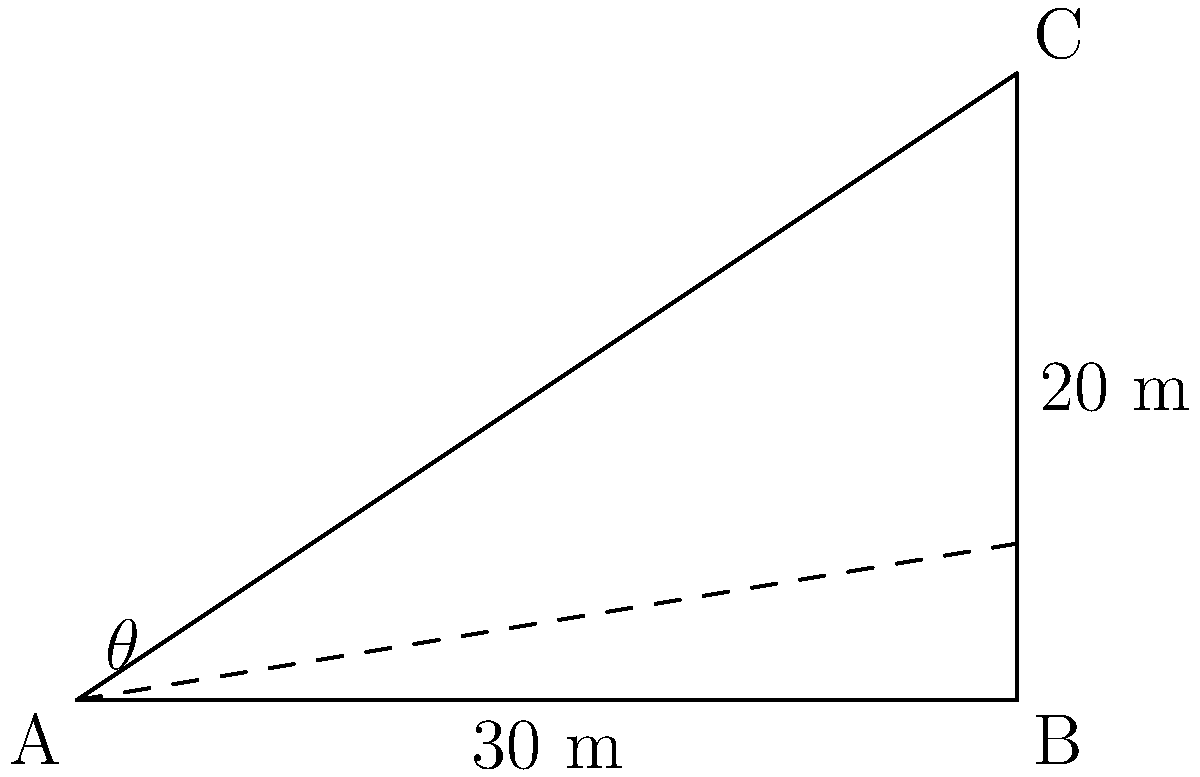As a computer science student working on a project involving 3D graphics and trigonometry, you need to calculate the angle of elevation for proper camera positioning. Given a building with a height of 20 meters and an observer standing 30 meters away from its base, what is the angle of elevation (θ) from the observer's eye level to the top of the building? Round your answer to the nearest degree. To solve this problem, we'll use the tangent function from trigonometry. Here's a step-by-step approach:

1) In this scenario, we have a right triangle where:
   - The adjacent side (distance from the observer to the building) is 30 meters
   - The opposite side (height of the building) is 20 meters
   - We need to find the angle θ

2) The tangent of an angle in a right triangle is defined as the ratio of the opposite side to the adjacent side:

   $$\tan(\theta) = \frac{\text{opposite}}{\text{adjacent}}$$

3) Substituting our known values:

   $$\tan(\theta) = \frac{20}{30}$$

4) Simplify the fraction:

   $$\tan(\theta) = \frac{2}{3}$$

5) To find θ, we need to use the inverse tangent (arctan or tan^(-1)) function:

   $$\theta = \tan^{-1}\left(\frac{2}{3}\right)$$

6) Using a calculator or programming function to compute this:

   $$\theta \approx 33.69° $$

7) Rounding to the nearest degree:

   $$\theta \approx 34°$$

Thus, the angle of elevation from the observer to the top of the building is approximately 34 degrees.
Answer: 34° 